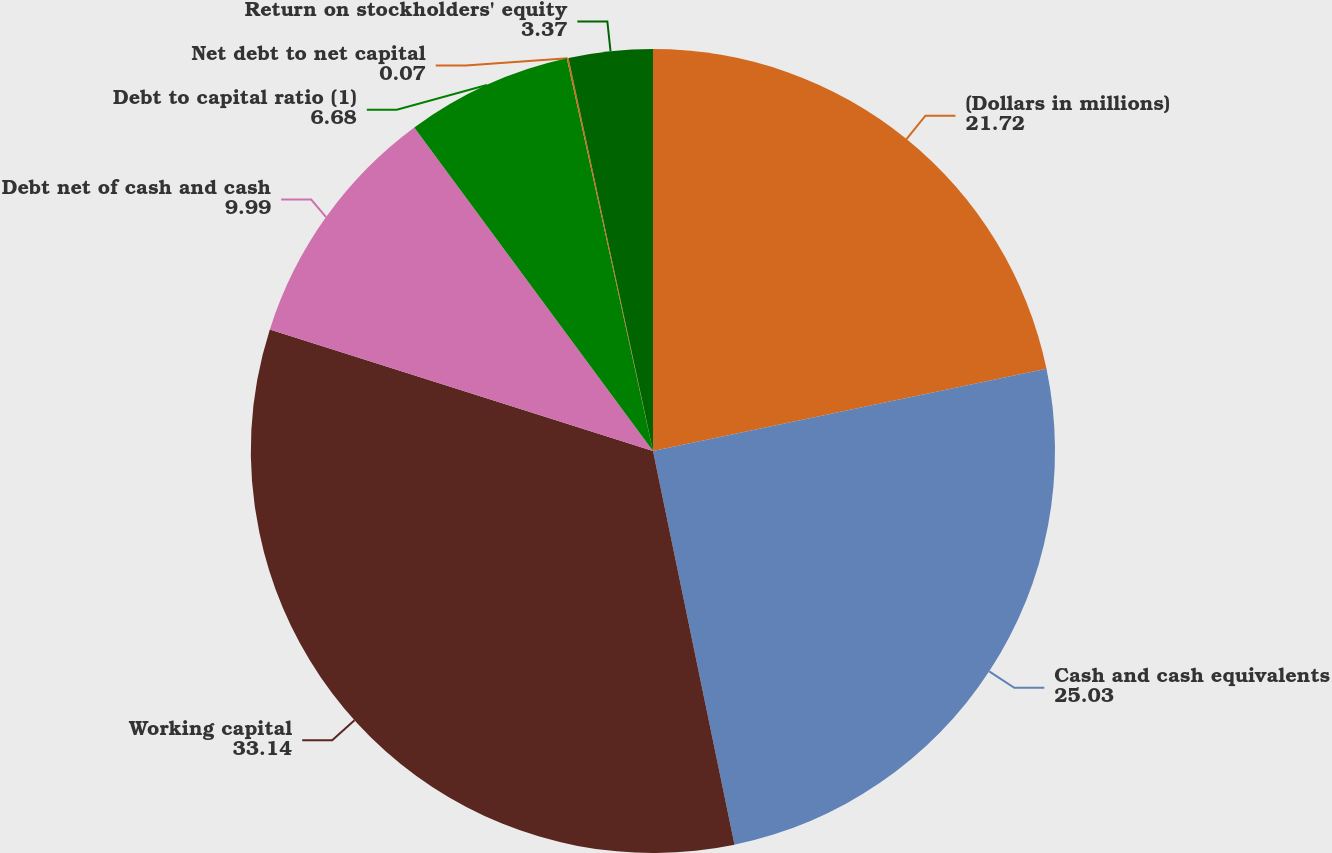Convert chart. <chart><loc_0><loc_0><loc_500><loc_500><pie_chart><fcel>(Dollars in millions)<fcel>Cash and cash equivalents<fcel>Working capital<fcel>Debt net of cash and cash<fcel>Debt to capital ratio (1)<fcel>Net debt to net capital<fcel>Return on stockholders' equity<nl><fcel>21.72%<fcel>25.03%<fcel>33.14%<fcel>9.99%<fcel>6.68%<fcel>0.07%<fcel>3.37%<nl></chart> 